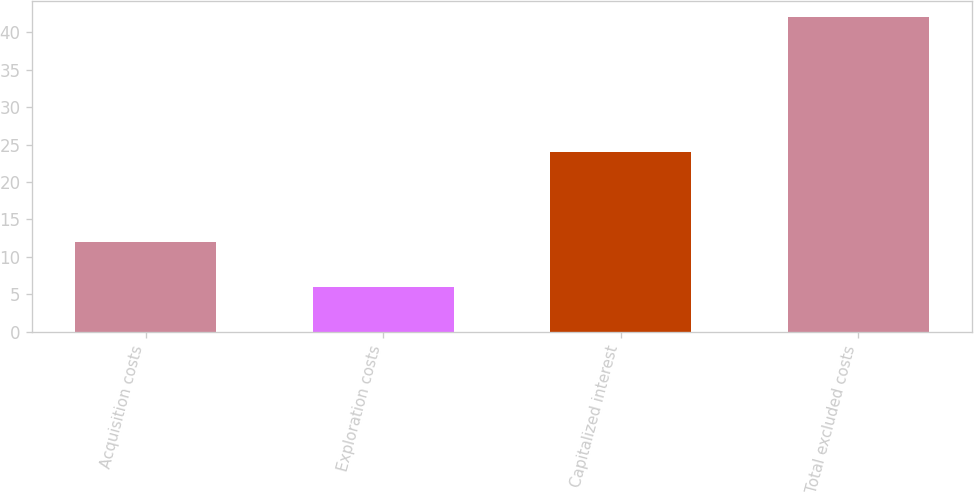Convert chart. <chart><loc_0><loc_0><loc_500><loc_500><bar_chart><fcel>Acquisition costs<fcel>Exploration costs<fcel>Capitalized interest<fcel>Total excluded costs<nl><fcel>12<fcel>6<fcel>24<fcel>42<nl></chart> 